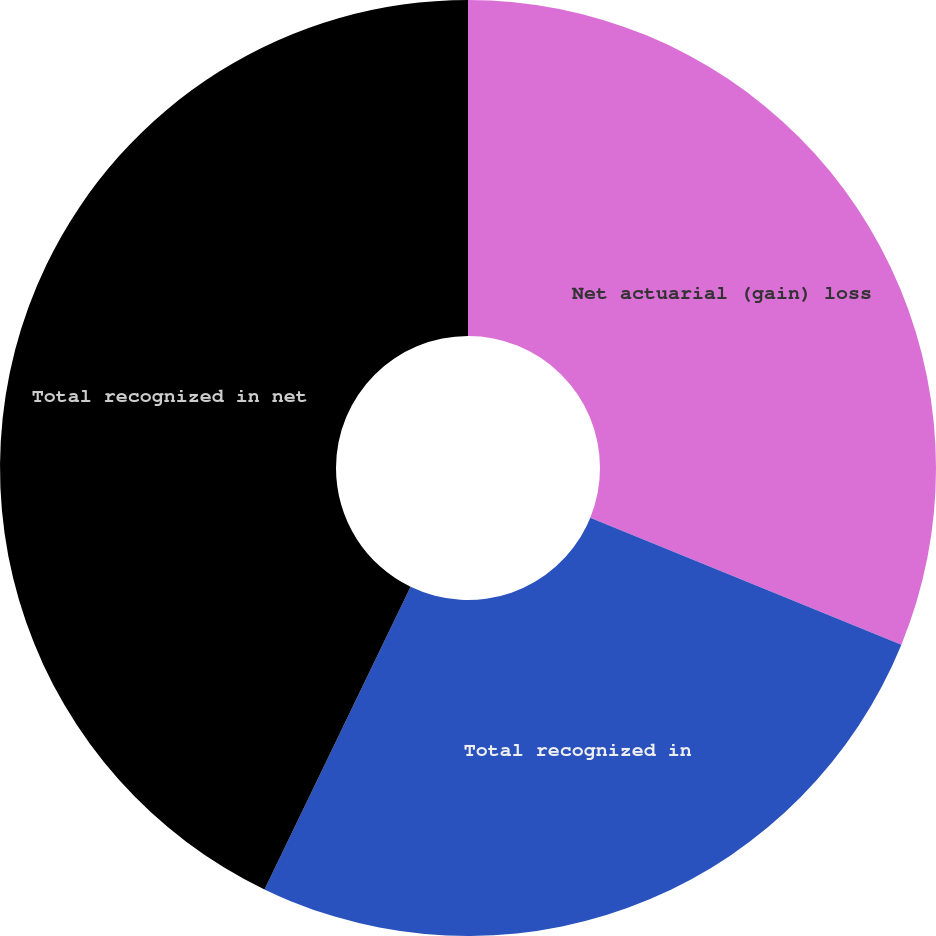Convert chart. <chart><loc_0><loc_0><loc_500><loc_500><pie_chart><fcel>Net actuarial (gain) loss<fcel>Total recognized in<fcel>Total recognized in net<nl><fcel>31.16%<fcel>26.0%<fcel>42.84%<nl></chart> 